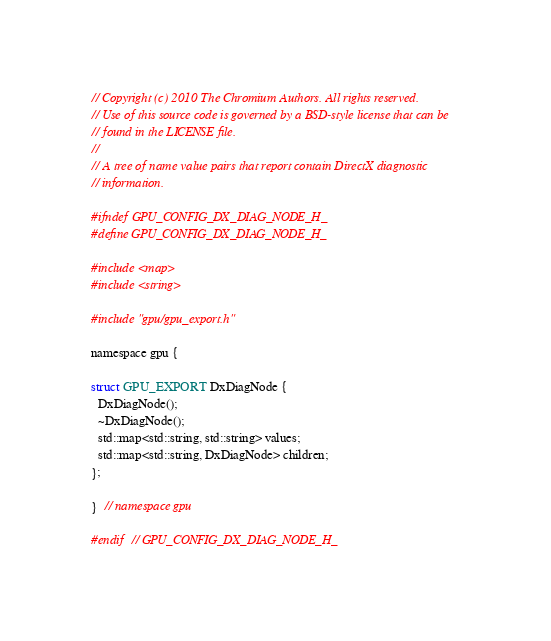Convert code to text. <code><loc_0><loc_0><loc_500><loc_500><_C_>// Copyright (c) 2010 The Chromium Authors. All rights reserved.
// Use of this source code is governed by a BSD-style license that can be
// found in the LICENSE file.
//
// A tree of name value pairs that report contain DirectX diagnostic
// information.

#ifndef GPU_CONFIG_DX_DIAG_NODE_H_
#define GPU_CONFIG_DX_DIAG_NODE_H_

#include <map>
#include <string>

#include "gpu/gpu_export.h"

namespace gpu {

struct GPU_EXPORT DxDiagNode {
  DxDiagNode();
  ~DxDiagNode();
  std::map<std::string, std::string> values;
  std::map<std::string, DxDiagNode> children;
};

}  // namespace gpu

#endif  // GPU_CONFIG_DX_DIAG_NODE_H_
</code> 